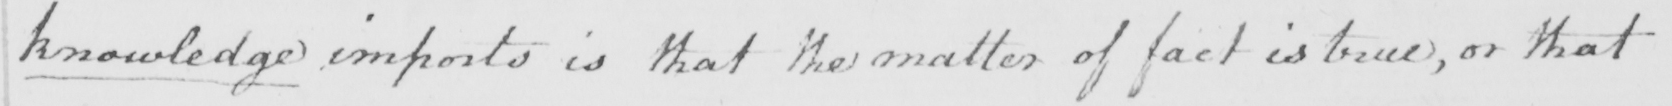What is written in this line of handwriting? knowledge imports is that the matter of fact is true , or that 